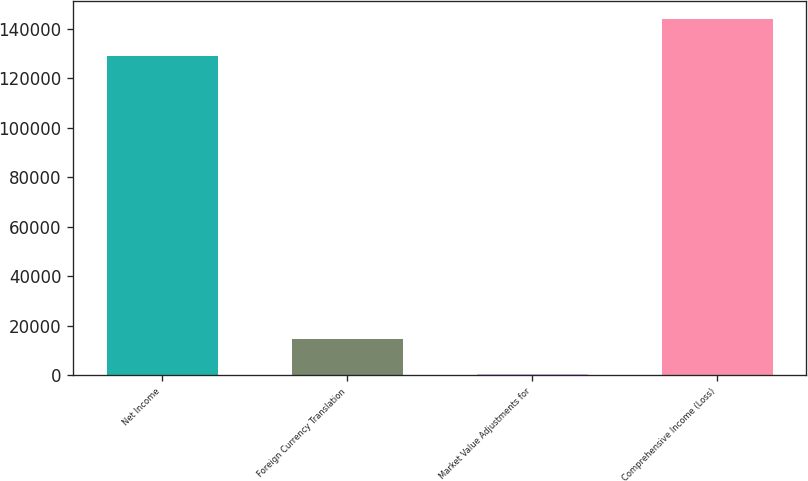Convert chart to OTSL. <chart><loc_0><loc_0><loc_500><loc_500><bar_chart><fcel>Net Income<fcel>Foreign Currency Translation<fcel>Market Value Adjustments for<fcel>Comprehensive Income (Loss)<nl><fcel>128863<fcel>14764.5<fcel>408<fcel>143973<nl></chart> 